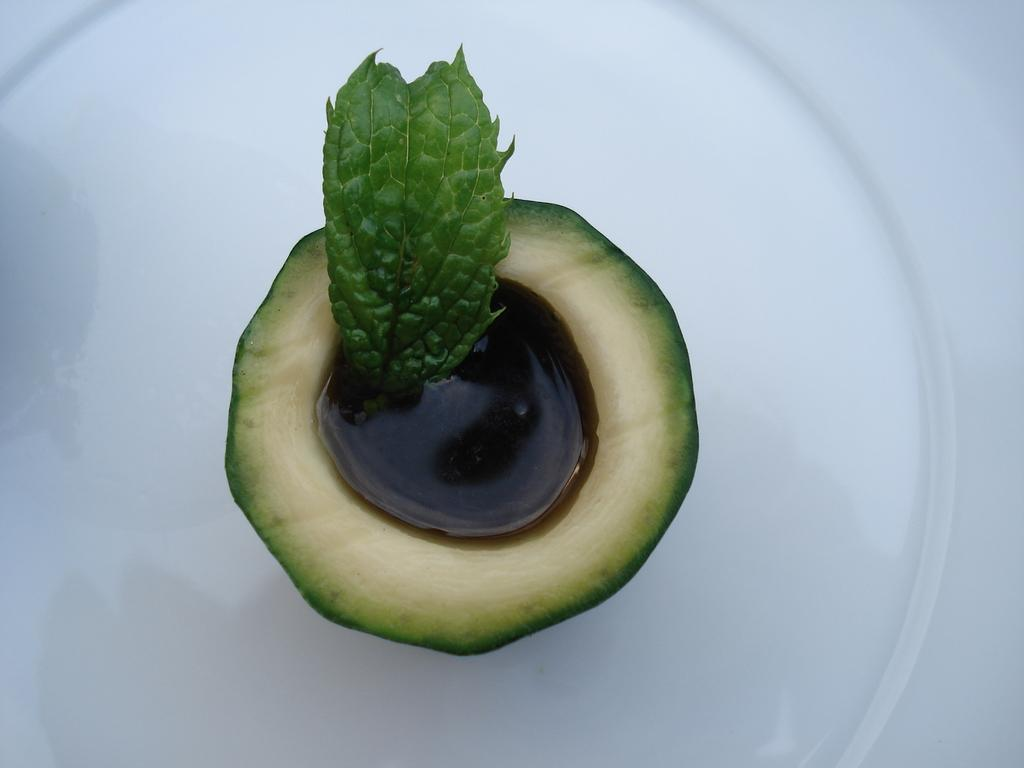What is the main object in the center of the image? There is a plate in the center of the image. What is on the plate? The plate contains a slice of an avocado fruit. Can you describe the appearance of the avocado slice? The slice of the avocado fruit has liquid visible in it, and there is a mint leaf in it. What statement can be seen written on the avocado slice in the image? There are no statements written on the avocado slice in the image; it is a fruit slice with liquid and a mint leaf. 